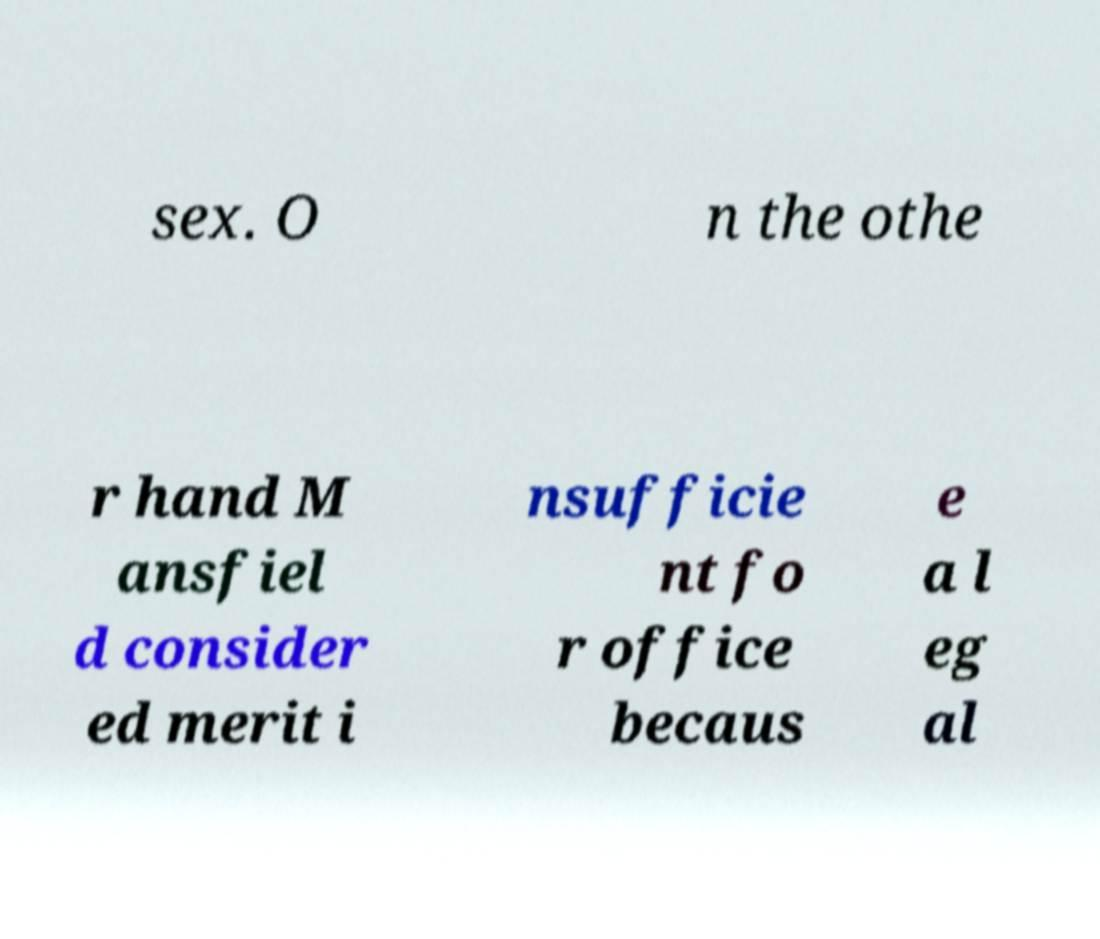Can you read and provide the text displayed in the image?This photo seems to have some interesting text. Can you extract and type it out for me? sex. O n the othe r hand M ansfiel d consider ed merit i nsufficie nt fo r office becaus e a l eg al 